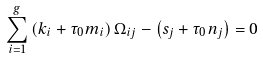Convert formula to latex. <formula><loc_0><loc_0><loc_500><loc_500>\sum _ { i = 1 } ^ { g } \left ( k _ { i } + \tau _ { 0 } m _ { i } \right ) \Omega _ { i j } - \left ( s _ { j } + \tau _ { 0 } n _ { j } \right ) = 0</formula> 